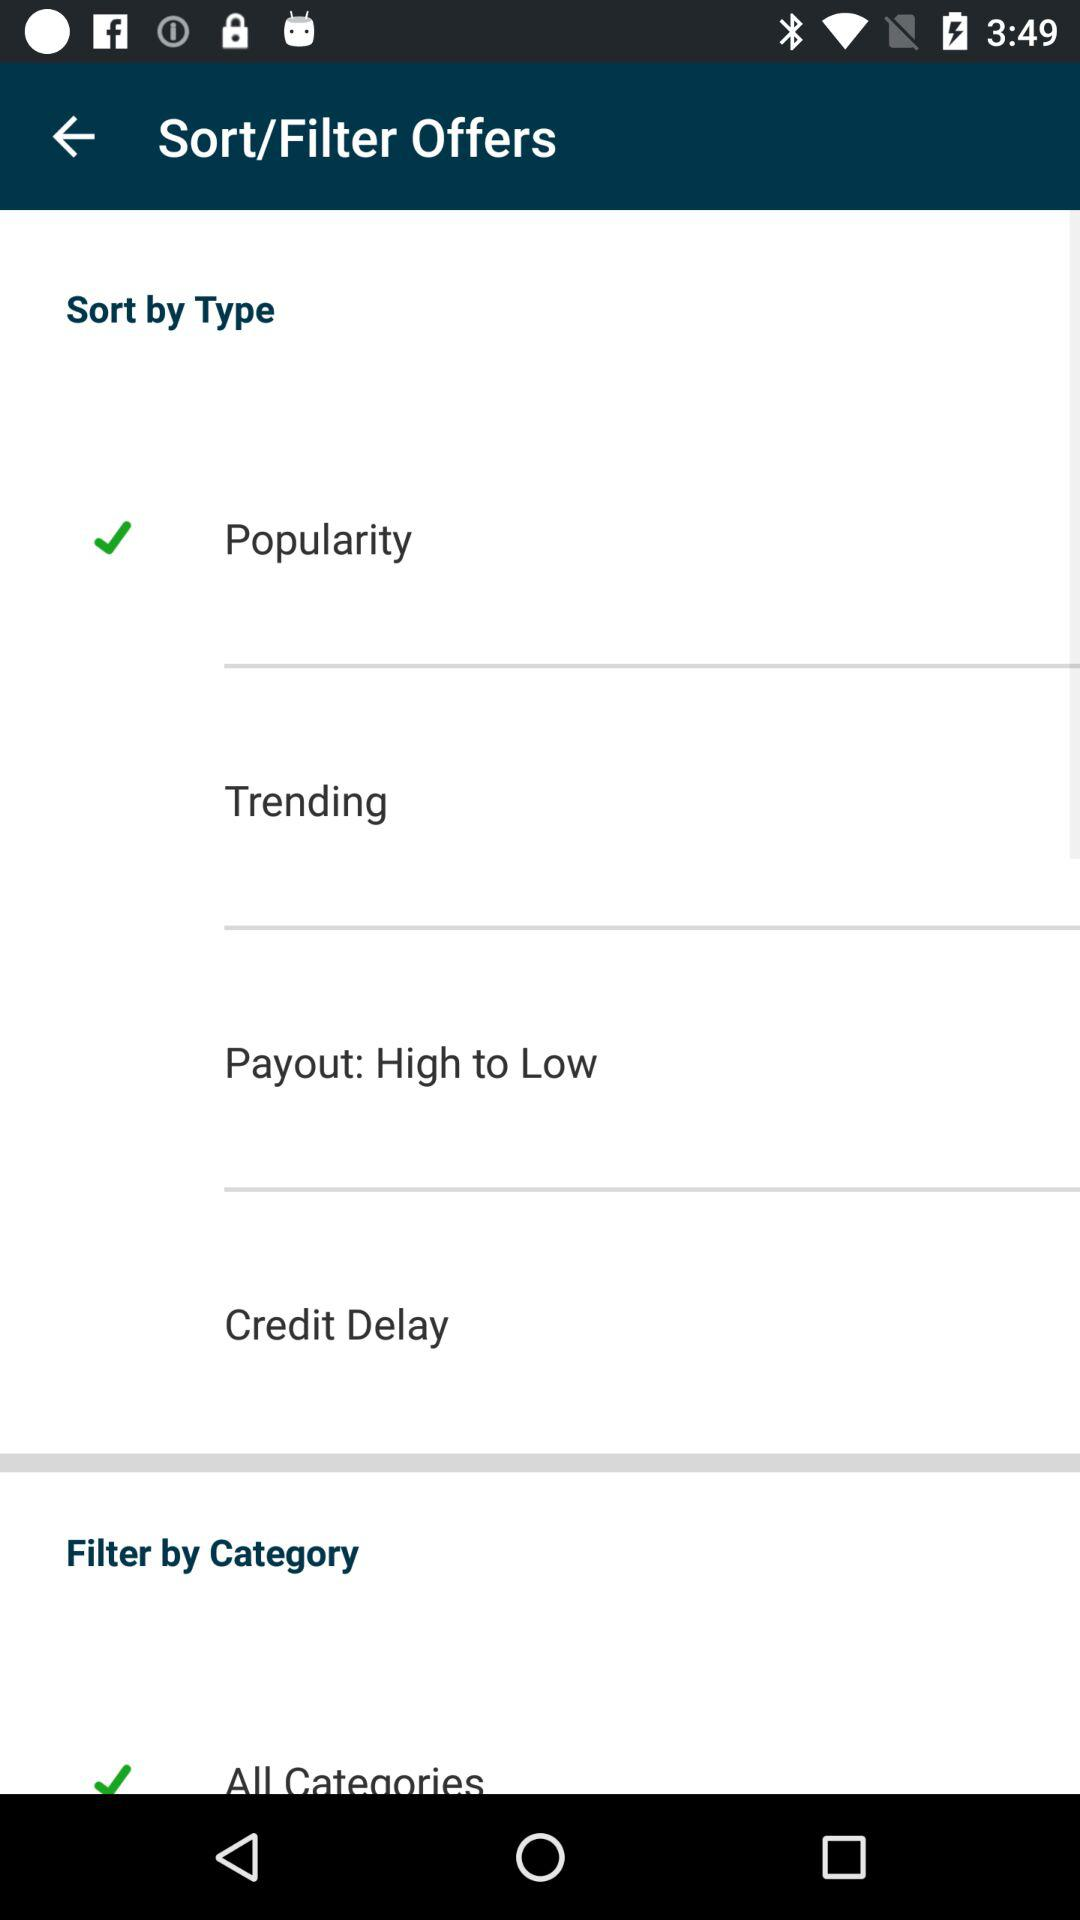What are the selected categories? The selected category is "All Categories". 